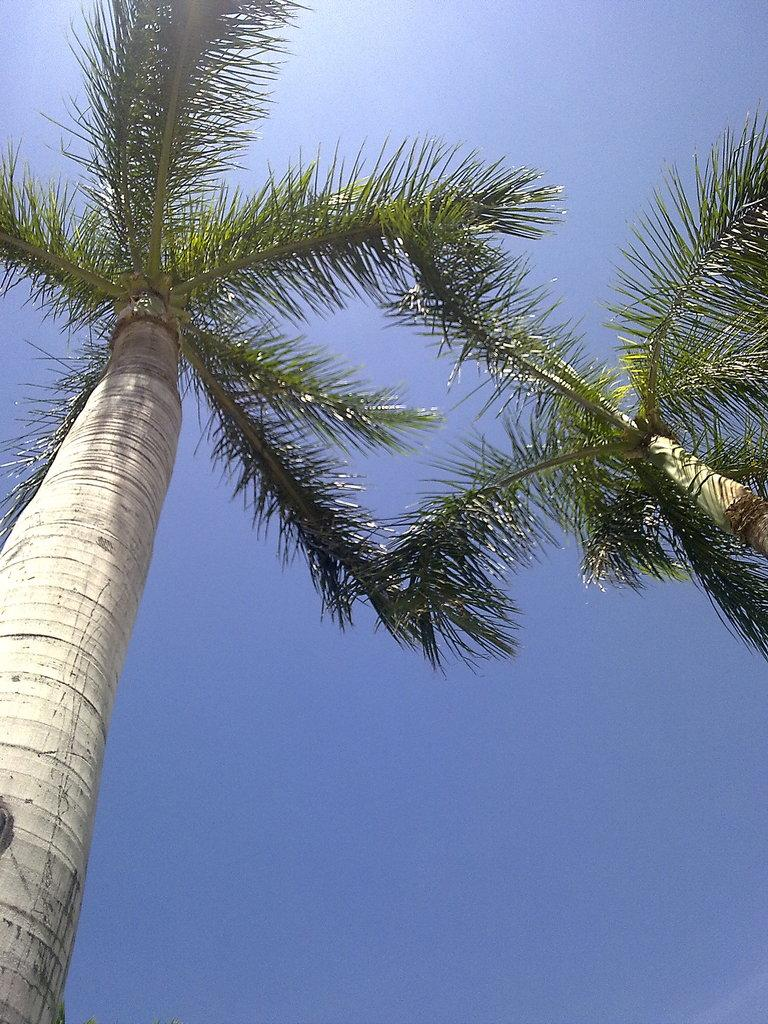What type of vegetation can be seen in the image? There are trees in the image. What part of the natural environment is visible in the image? The sky is visible in the image. How would you describe the sky in the image? The sky appears to be cloudy in the image. Can you tell me how many teeth are visible in the image? There are no teeth present in the image; it features trees and a cloudy sky. What type of damage can be seen in the image as a result of the earthquake? There is no earthquake or any damage visible in the image; it only shows trees and a cloudy sky. 